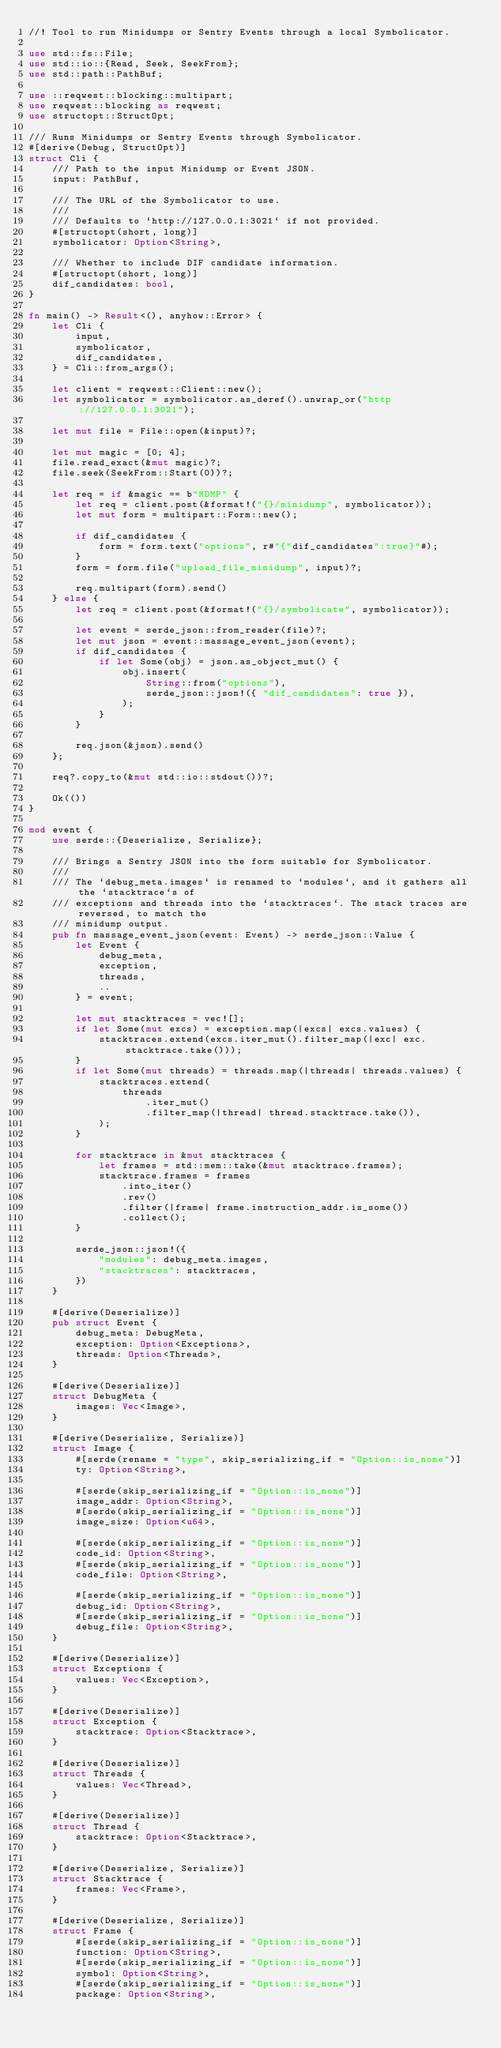Convert code to text. <code><loc_0><loc_0><loc_500><loc_500><_Rust_>//! Tool to run Minidumps or Sentry Events through a local Symbolicator.

use std::fs::File;
use std::io::{Read, Seek, SeekFrom};
use std::path::PathBuf;

use ::reqwest::blocking::multipart;
use reqwest::blocking as reqwest;
use structopt::StructOpt;

/// Runs Minidumps or Sentry Events through Symbolicator.
#[derive(Debug, StructOpt)]
struct Cli {
    /// Path to the input Minidump or Event JSON.
    input: PathBuf,

    /// The URL of the Symbolicator to use.
    ///
    /// Defaults to `http://127.0.0.1:3021` if not provided.
    #[structopt(short, long)]
    symbolicator: Option<String>,

    /// Whether to include DIF candidate information.
    #[structopt(short, long)]
    dif_candidates: bool,
}

fn main() -> Result<(), anyhow::Error> {
    let Cli {
        input,
        symbolicator,
        dif_candidates,
    } = Cli::from_args();

    let client = reqwest::Client::new();
    let symbolicator = symbolicator.as_deref().unwrap_or("http://127.0.0.1:3021");

    let mut file = File::open(&input)?;

    let mut magic = [0; 4];
    file.read_exact(&mut magic)?;
    file.seek(SeekFrom::Start(0))?;

    let req = if &magic == b"MDMP" {
        let req = client.post(&format!("{}/minidump", symbolicator));
        let mut form = multipart::Form::new();

        if dif_candidates {
            form = form.text("options", r#"{"dif_candidates":true}"#);
        }
        form = form.file("upload_file_minidump", input)?;

        req.multipart(form).send()
    } else {
        let req = client.post(&format!("{}/symbolicate", symbolicator));

        let event = serde_json::from_reader(file)?;
        let mut json = event::massage_event_json(event);
        if dif_candidates {
            if let Some(obj) = json.as_object_mut() {
                obj.insert(
                    String::from("options"),
                    serde_json::json!({ "dif_candidates": true }),
                );
            }
        }

        req.json(&json).send()
    };

    req?.copy_to(&mut std::io::stdout())?;

    Ok(())
}

mod event {
    use serde::{Deserialize, Serialize};

    /// Brings a Sentry JSON into the form suitable for Symbolicator.
    ///
    /// The `debug_meta.images` is renamed to `modules`, and it gathers all the `stacktrace`s of
    /// exceptions and threads into the `stacktraces`. The stack traces are reversed, to match the
    /// minidump output.
    pub fn massage_event_json(event: Event) -> serde_json::Value {
        let Event {
            debug_meta,
            exception,
            threads,
            ..
        } = event;

        let mut stacktraces = vec![];
        if let Some(mut excs) = exception.map(|excs| excs.values) {
            stacktraces.extend(excs.iter_mut().filter_map(|exc| exc.stacktrace.take()));
        }
        if let Some(mut threads) = threads.map(|threads| threads.values) {
            stacktraces.extend(
                threads
                    .iter_mut()
                    .filter_map(|thread| thread.stacktrace.take()),
            );
        }

        for stacktrace in &mut stacktraces {
            let frames = std::mem::take(&mut stacktrace.frames);
            stacktrace.frames = frames
                .into_iter()
                .rev()
                .filter(|frame| frame.instruction_addr.is_some())
                .collect();
        }

        serde_json::json!({
            "modules": debug_meta.images,
            "stacktraces": stacktraces,
        })
    }

    #[derive(Deserialize)]
    pub struct Event {
        debug_meta: DebugMeta,
        exception: Option<Exceptions>,
        threads: Option<Threads>,
    }

    #[derive(Deserialize)]
    struct DebugMeta {
        images: Vec<Image>,
    }

    #[derive(Deserialize, Serialize)]
    struct Image {
        #[serde(rename = "type", skip_serializing_if = "Option::is_none")]
        ty: Option<String>,

        #[serde(skip_serializing_if = "Option::is_none")]
        image_addr: Option<String>,
        #[serde(skip_serializing_if = "Option::is_none")]
        image_size: Option<u64>,

        #[serde(skip_serializing_if = "Option::is_none")]
        code_id: Option<String>,
        #[serde(skip_serializing_if = "Option::is_none")]
        code_file: Option<String>,

        #[serde(skip_serializing_if = "Option::is_none")]
        debug_id: Option<String>,
        #[serde(skip_serializing_if = "Option::is_none")]
        debug_file: Option<String>,
    }

    #[derive(Deserialize)]
    struct Exceptions {
        values: Vec<Exception>,
    }

    #[derive(Deserialize)]
    struct Exception {
        stacktrace: Option<Stacktrace>,
    }

    #[derive(Deserialize)]
    struct Threads {
        values: Vec<Thread>,
    }

    #[derive(Deserialize)]
    struct Thread {
        stacktrace: Option<Stacktrace>,
    }

    #[derive(Deserialize, Serialize)]
    struct Stacktrace {
        frames: Vec<Frame>,
    }

    #[derive(Deserialize, Serialize)]
    struct Frame {
        #[serde(skip_serializing_if = "Option::is_none")]
        function: Option<String>,
        #[serde(skip_serializing_if = "Option::is_none")]
        symbol: Option<String>,
        #[serde(skip_serializing_if = "Option::is_none")]
        package: Option<String>,</code> 